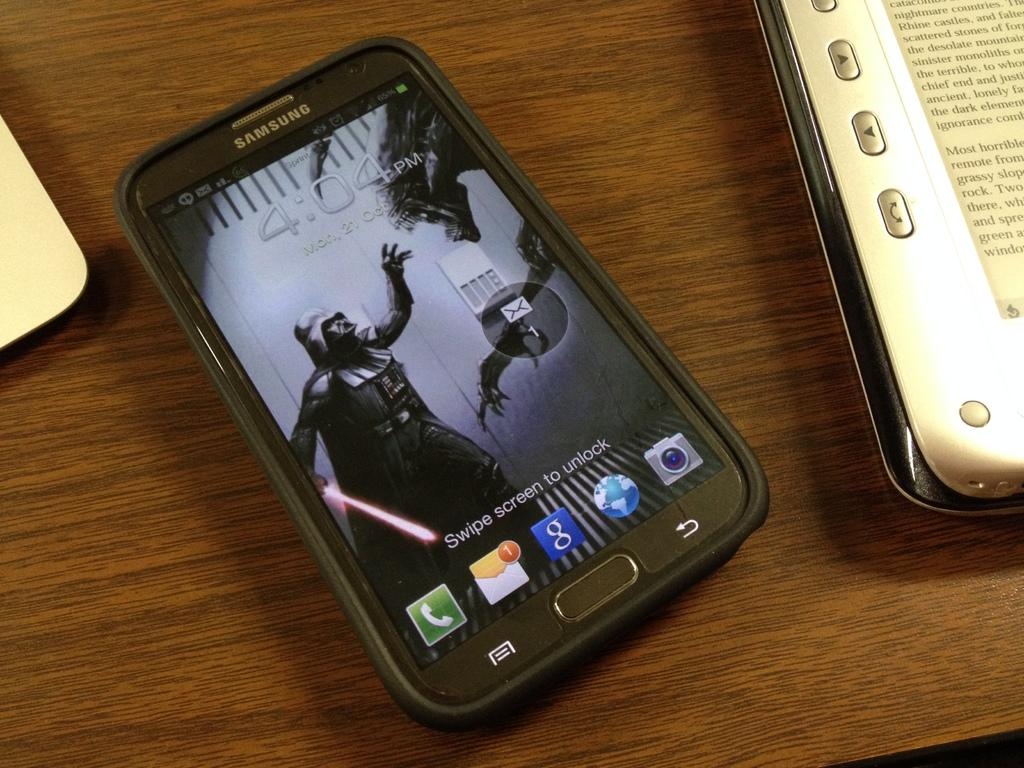Provide a one-sentence caption for the provided image. The Samsung smartphone has a screensaver of Darth Vader from Star wars. 